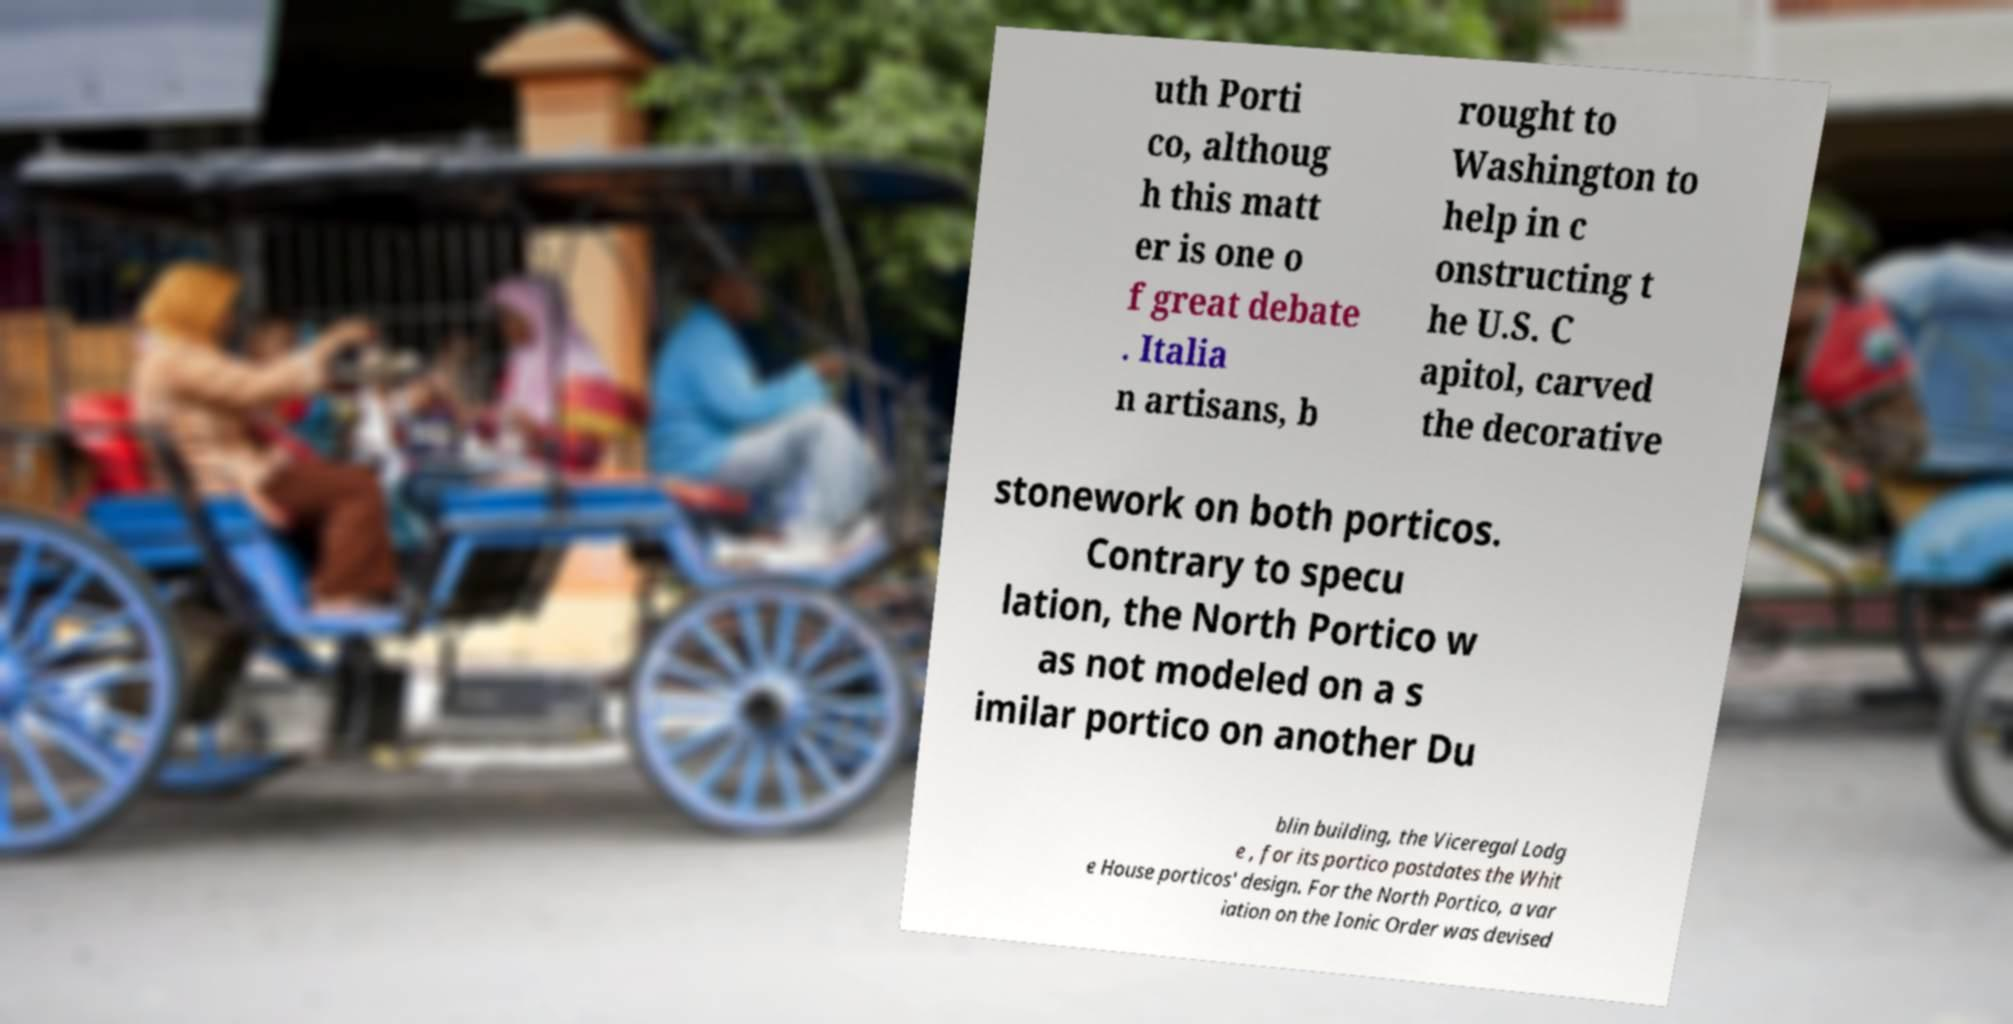For documentation purposes, I need the text within this image transcribed. Could you provide that? uth Porti co, althoug h this matt er is one o f great debate . Italia n artisans, b rought to Washington to help in c onstructing t he U.S. C apitol, carved the decorative stonework on both porticos. Contrary to specu lation, the North Portico w as not modeled on a s imilar portico on another Du blin building, the Viceregal Lodg e , for its portico postdates the Whit e House porticos' design. For the North Portico, a var iation on the Ionic Order was devised 